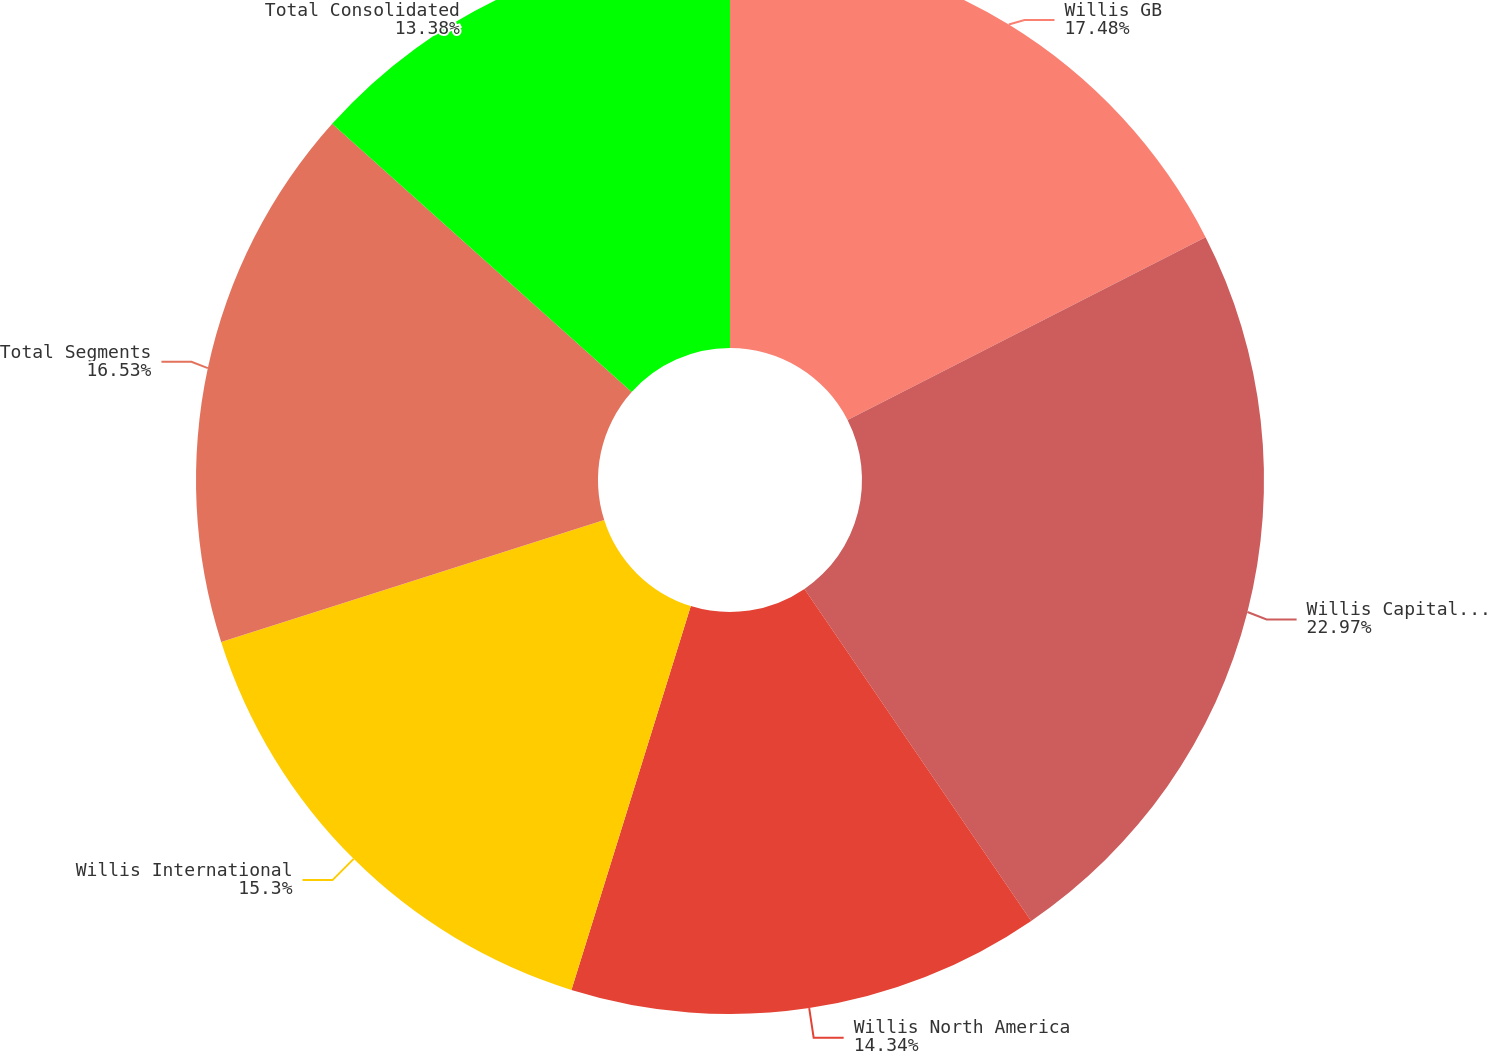Convert chart to OTSL. <chart><loc_0><loc_0><loc_500><loc_500><pie_chart><fcel>Willis GB<fcel>Willis Capital Wholesale &<fcel>Willis North America<fcel>Willis International<fcel>Total Segments<fcel>Total Consolidated<nl><fcel>17.49%<fcel>22.98%<fcel>14.34%<fcel>15.3%<fcel>16.53%<fcel>13.38%<nl></chart> 